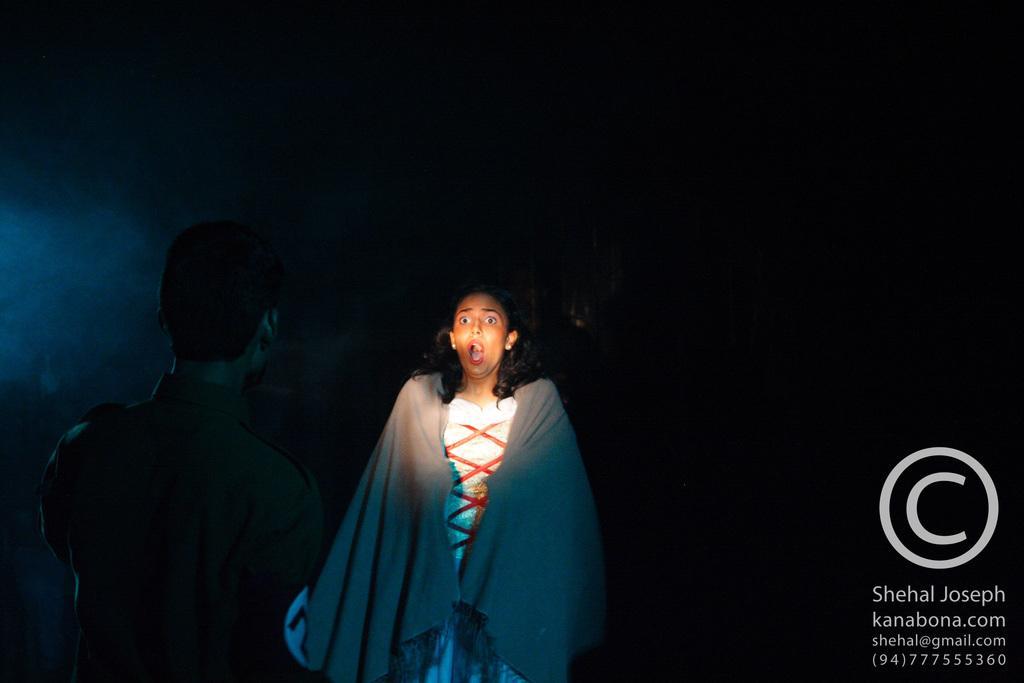How would you summarize this image in a sentence or two? In the image I can see one girl is standing. On the right side of the image I can see some written text. 